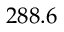Convert formula to latex. <formula><loc_0><loc_0><loc_500><loc_500>2 8 8 . 6</formula> 